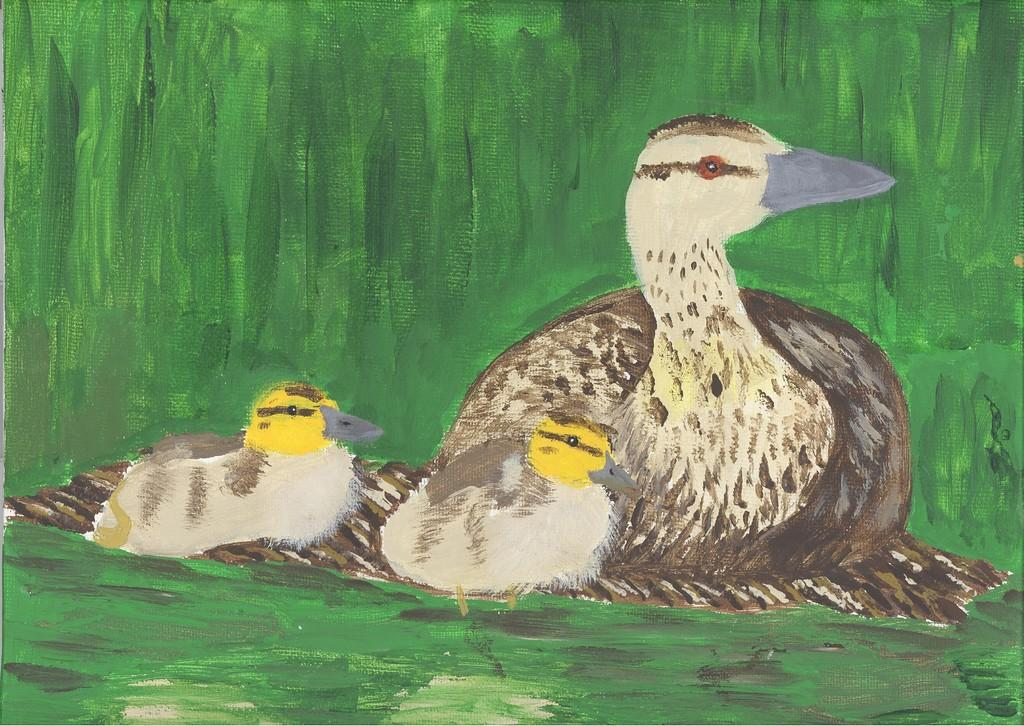What is the main subject of the painting in the image? The painting depicts a duck. Are there any other elements in the painting besides the duck? Yes, the duck has ducklings in the painting. What type of soap is being used by the duck in the image? There is no soap present in the image, as it features a painting of a duck with ducklings. 